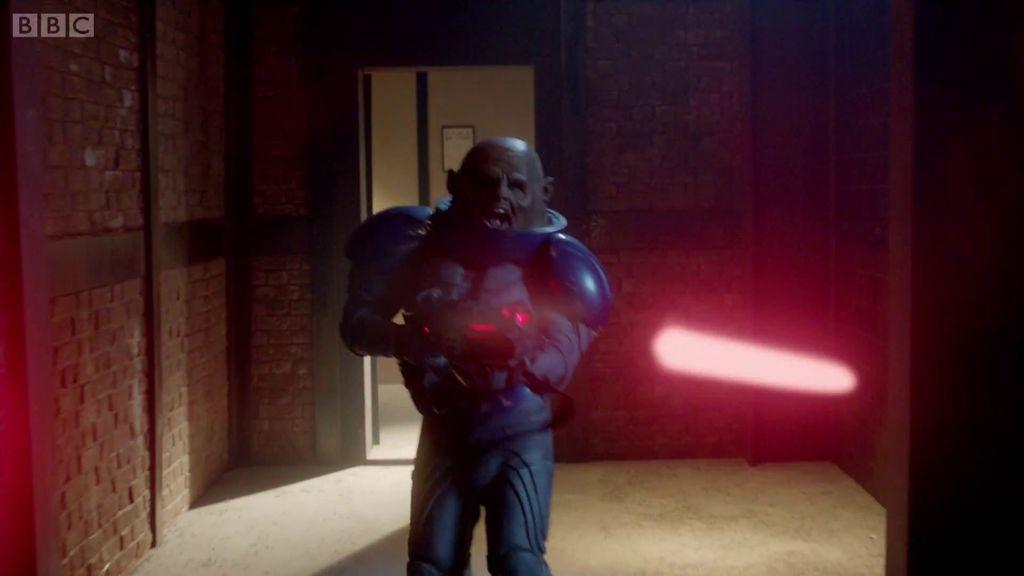What is the person in the image wearing? The person in the image is wearing a costume. What can be seen on the right side of the image? There is a light on the right side of the image. What is written or displayed in the top left corner of the image? Text is visible in the top left corner of the image. What type of wall is present in the image? There is a brick wall in the image. What is attached to the brick wall in the image? There is a board on the wall in the image. What type of badge can be seen on the person's costume in the image? There is no badge visible on the person's costume in the image. Can you describe the marble floor in the image? There is no marble floor present in the image; it features a brick wall. 